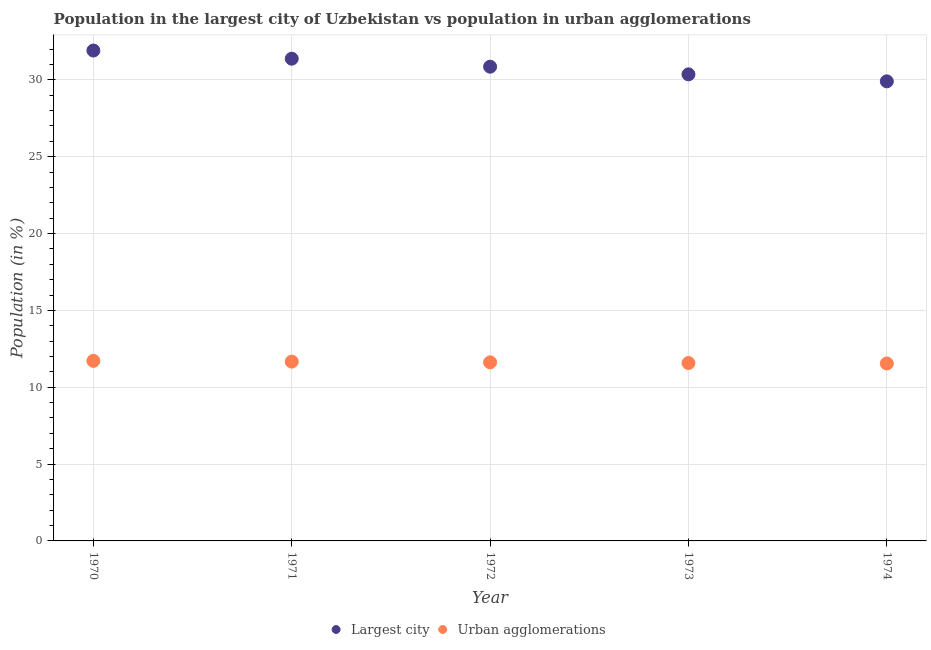How many different coloured dotlines are there?
Your answer should be very brief. 2. Is the number of dotlines equal to the number of legend labels?
Ensure brevity in your answer.  Yes. What is the population in the largest city in 1973?
Ensure brevity in your answer.  30.36. Across all years, what is the maximum population in the largest city?
Your answer should be very brief. 31.91. Across all years, what is the minimum population in the largest city?
Your answer should be compact. 29.91. In which year was the population in urban agglomerations maximum?
Provide a short and direct response. 1970. In which year was the population in urban agglomerations minimum?
Ensure brevity in your answer.  1974. What is the total population in urban agglomerations in the graph?
Keep it short and to the point. 58.13. What is the difference between the population in the largest city in 1970 and that in 1974?
Your answer should be very brief. 2. What is the difference between the population in urban agglomerations in 1970 and the population in the largest city in 1971?
Your answer should be compact. -19.66. What is the average population in the largest city per year?
Provide a succinct answer. 30.88. In the year 1972, what is the difference between the population in urban agglomerations and population in the largest city?
Ensure brevity in your answer.  -19.24. What is the ratio of the population in the largest city in 1973 to that in 1974?
Offer a terse response. 1.02. What is the difference between the highest and the second highest population in urban agglomerations?
Your answer should be compact. 0.05. What is the difference between the highest and the lowest population in the largest city?
Offer a terse response. 2. How many dotlines are there?
Provide a short and direct response. 2. What is the difference between two consecutive major ticks on the Y-axis?
Offer a very short reply. 5. Are the values on the major ticks of Y-axis written in scientific E-notation?
Ensure brevity in your answer.  No. Does the graph contain any zero values?
Your response must be concise. No. Does the graph contain grids?
Ensure brevity in your answer.  Yes. How many legend labels are there?
Offer a terse response. 2. How are the legend labels stacked?
Make the answer very short. Horizontal. What is the title of the graph?
Give a very brief answer. Population in the largest city of Uzbekistan vs population in urban agglomerations. What is the label or title of the Y-axis?
Give a very brief answer. Population (in %). What is the Population (in %) in Largest city in 1970?
Provide a short and direct response. 31.91. What is the Population (in %) in Urban agglomerations in 1970?
Provide a succinct answer. 11.72. What is the Population (in %) in Largest city in 1971?
Your response must be concise. 31.38. What is the Population (in %) of Urban agglomerations in 1971?
Give a very brief answer. 11.67. What is the Population (in %) in Largest city in 1972?
Provide a succinct answer. 30.86. What is the Population (in %) in Urban agglomerations in 1972?
Your answer should be compact. 11.62. What is the Population (in %) of Largest city in 1973?
Provide a short and direct response. 30.36. What is the Population (in %) of Urban agglomerations in 1973?
Ensure brevity in your answer.  11.58. What is the Population (in %) in Largest city in 1974?
Ensure brevity in your answer.  29.91. What is the Population (in %) of Urban agglomerations in 1974?
Offer a very short reply. 11.55. Across all years, what is the maximum Population (in %) of Largest city?
Offer a terse response. 31.91. Across all years, what is the maximum Population (in %) of Urban agglomerations?
Your answer should be compact. 11.72. Across all years, what is the minimum Population (in %) in Largest city?
Offer a terse response. 29.91. Across all years, what is the minimum Population (in %) of Urban agglomerations?
Offer a terse response. 11.55. What is the total Population (in %) of Largest city in the graph?
Ensure brevity in your answer.  154.42. What is the total Population (in %) of Urban agglomerations in the graph?
Offer a very short reply. 58.13. What is the difference between the Population (in %) in Largest city in 1970 and that in 1971?
Provide a short and direct response. 0.53. What is the difference between the Population (in %) of Urban agglomerations in 1970 and that in 1971?
Provide a short and direct response. 0.05. What is the difference between the Population (in %) of Largest city in 1970 and that in 1972?
Your response must be concise. 1.05. What is the difference between the Population (in %) in Urban agglomerations in 1970 and that in 1972?
Your answer should be compact. 0.1. What is the difference between the Population (in %) in Largest city in 1970 and that in 1973?
Give a very brief answer. 1.55. What is the difference between the Population (in %) in Urban agglomerations in 1970 and that in 1973?
Your answer should be very brief. 0.14. What is the difference between the Population (in %) of Largest city in 1970 and that in 1974?
Your answer should be compact. 2. What is the difference between the Population (in %) in Urban agglomerations in 1970 and that in 1974?
Your response must be concise. 0.17. What is the difference between the Population (in %) of Largest city in 1971 and that in 1972?
Offer a very short reply. 0.52. What is the difference between the Population (in %) in Urban agglomerations in 1971 and that in 1972?
Keep it short and to the point. 0.05. What is the difference between the Population (in %) in Largest city in 1971 and that in 1973?
Your answer should be very brief. 1.02. What is the difference between the Population (in %) of Urban agglomerations in 1971 and that in 1973?
Your answer should be very brief. 0.09. What is the difference between the Population (in %) in Largest city in 1971 and that in 1974?
Offer a terse response. 1.47. What is the difference between the Population (in %) in Urban agglomerations in 1971 and that in 1974?
Ensure brevity in your answer.  0.12. What is the difference between the Population (in %) in Largest city in 1972 and that in 1973?
Keep it short and to the point. 0.5. What is the difference between the Population (in %) of Urban agglomerations in 1972 and that in 1973?
Make the answer very short. 0.04. What is the difference between the Population (in %) in Largest city in 1972 and that in 1974?
Offer a very short reply. 0.95. What is the difference between the Population (in %) in Urban agglomerations in 1972 and that in 1974?
Provide a succinct answer. 0.07. What is the difference between the Population (in %) of Largest city in 1973 and that in 1974?
Your response must be concise. 0.46. What is the difference between the Population (in %) of Urban agglomerations in 1973 and that in 1974?
Your answer should be very brief. 0.03. What is the difference between the Population (in %) in Largest city in 1970 and the Population (in %) in Urban agglomerations in 1971?
Provide a short and direct response. 20.24. What is the difference between the Population (in %) in Largest city in 1970 and the Population (in %) in Urban agglomerations in 1972?
Your response must be concise. 20.29. What is the difference between the Population (in %) of Largest city in 1970 and the Population (in %) of Urban agglomerations in 1973?
Provide a succinct answer. 20.33. What is the difference between the Population (in %) in Largest city in 1970 and the Population (in %) in Urban agglomerations in 1974?
Offer a very short reply. 20.36. What is the difference between the Population (in %) of Largest city in 1971 and the Population (in %) of Urban agglomerations in 1972?
Ensure brevity in your answer.  19.76. What is the difference between the Population (in %) in Largest city in 1971 and the Population (in %) in Urban agglomerations in 1973?
Ensure brevity in your answer.  19.8. What is the difference between the Population (in %) of Largest city in 1971 and the Population (in %) of Urban agglomerations in 1974?
Ensure brevity in your answer.  19.83. What is the difference between the Population (in %) in Largest city in 1972 and the Population (in %) in Urban agglomerations in 1973?
Provide a short and direct response. 19.28. What is the difference between the Population (in %) in Largest city in 1972 and the Population (in %) in Urban agglomerations in 1974?
Your answer should be very brief. 19.31. What is the difference between the Population (in %) of Largest city in 1973 and the Population (in %) of Urban agglomerations in 1974?
Give a very brief answer. 18.82. What is the average Population (in %) of Largest city per year?
Give a very brief answer. 30.88. What is the average Population (in %) of Urban agglomerations per year?
Give a very brief answer. 11.63. In the year 1970, what is the difference between the Population (in %) of Largest city and Population (in %) of Urban agglomerations?
Provide a short and direct response. 20.2. In the year 1971, what is the difference between the Population (in %) in Largest city and Population (in %) in Urban agglomerations?
Your response must be concise. 19.71. In the year 1972, what is the difference between the Population (in %) in Largest city and Population (in %) in Urban agglomerations?
Provide a succinct answer. 19.24. In the year 1973, what is the difference between the Population (in %) in Largest city and Population (in %) in Urban agglomerations?
Offer a very short reply. 18.78. In the year 1974, what is the difference between the Population (in %) of Largest city and Population (in %) of Urban agglomerations?
Make the answer very short. 18.36. What is the ratio of the Population (in %) in Largest city in 1970 to that in 1971?
Provide a short and direct response. 1.02. What is the ratio of the Population (in %) of Largest city in 1970 to that in 1972?
Ensure brevity in your answer.  1.03. What is the ratio of the Population (in %) of Urban agglomerations in 1970 to that in 1972?
Offer a terse response. 1.01. What is the ratio of the Population (in %) in Largest city in 1970 to that in 1973?
Ensure brevity in your answer.  1.05. What is the ratio of the Population (in %) of Urban agglomerations in 1970 to that in 1973?
Keep it short and to the point. 1.01. What is the ratio of the Population (in %) in Largest city in 1970 to that in 1974?
Your answer should be very brief. 1.07. What is the ratio of the Population (in %) of Urban agglomerations in 1970 to that in 1974?
Provide a short and direct response. 1.01. What is the ratio of the Population (in %) in Largest city in 1971 to that in 1972?
Keep it short and to the point. 1.02. What is the ratio of the Population (in %) of Largest city in 1971 to that in 1973?
Provide a succinct answer. 1.03. What is the ratio of the Population (in %) in Urban agglomerations in 1971 to that in 1973?
Ensure brevity in your answer.  1.01. What is the ratio of the Population (in %) of Largest city in 1971 to that in 1974?
Give a very brief answer. 1.05. What is the ratio of the Population (in %) of Urban agglomerations in 1971 to that in 1974?
Your answer should be very brief. 1.01. What is the ratio of the Population (in %) in Largest city in 1972 to that in 1973?
Offer a very short reply. 1.02. What is the ratio of the Population (in %) in Largest city in 1972 to that in 1974?
Your answer should be compact. 1.03. What is the ratio of the Population (in %) of Urban agglomerations in 1972 to that in 1974?
Your answer should be very brief. 1.01. What is the ratio of the Population (in %) in Largest city in 1973 to that in 1974?
Make the answer very short. 1.02. What is the difference between the highest and the second highest Population (in %) of Largest city?
Make the answer very short. 0.53. What is the difference between the highest and the second highest Population (in %) in Urban agglomerations?
Provide a short and direct response. 0.05. What is the difference between the highest and the lowest Population (in %) in Largest city?
Offer a terse response. 2. What is the difference between the highest and the lowest Population (in %) of Urban agglomerations?
Provide a short and direct response. 0.17. 